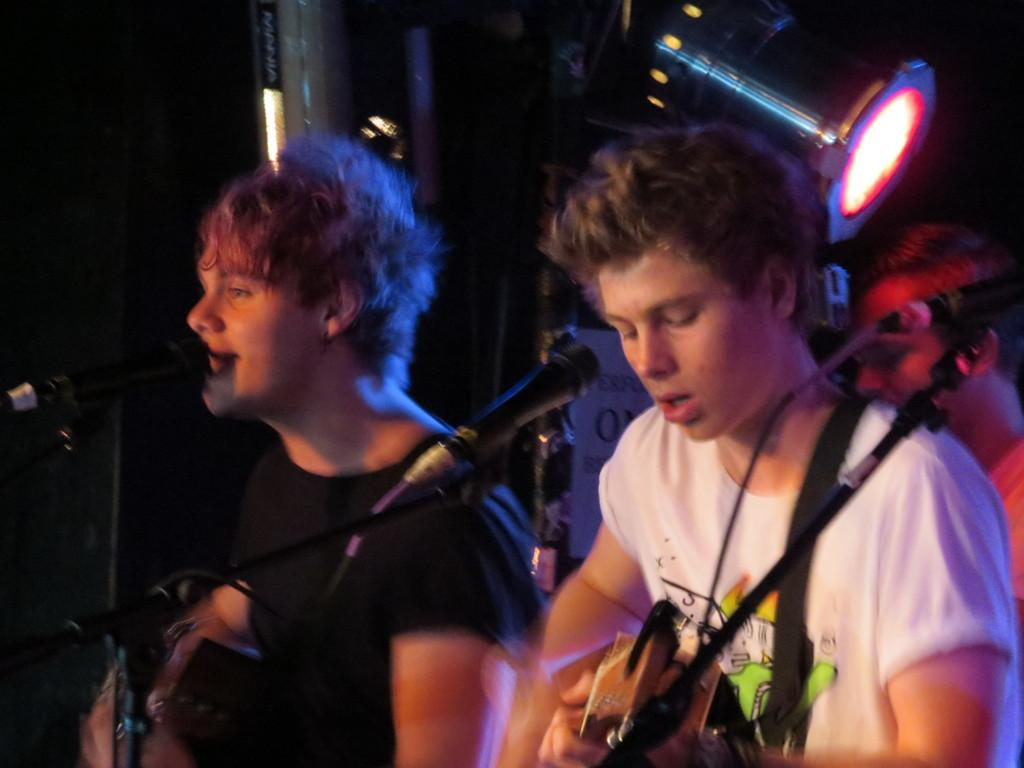How many people are in the image? There are three people in the image. What are the people doing in the image? The people are singing and playing musical instruments. Can you describe any other elements in the image? There is a light visible in the image. How many houses are visible in the image? There are no houses visible in the image. What type of government is represented by the people in the image? The image does not depict any specific government or political affiliation. 